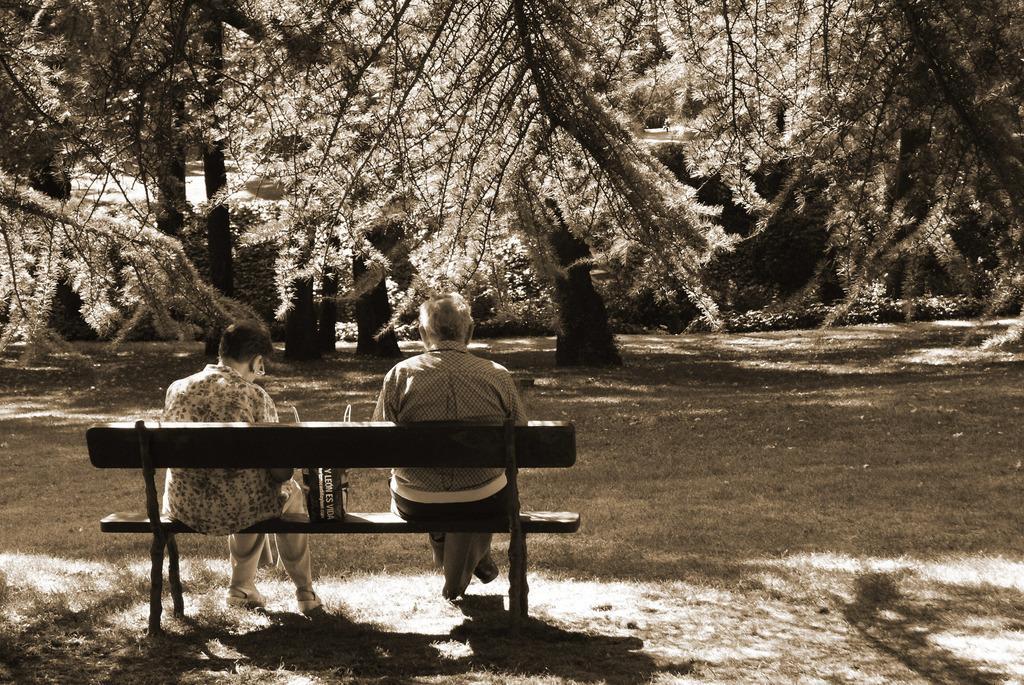In one or two sentences, can you explain what this image depicts? In this image we can see two persons are sitting on the bench, there is a bag on it, there are plants, trees, and the picture is taken in black and white mode. 